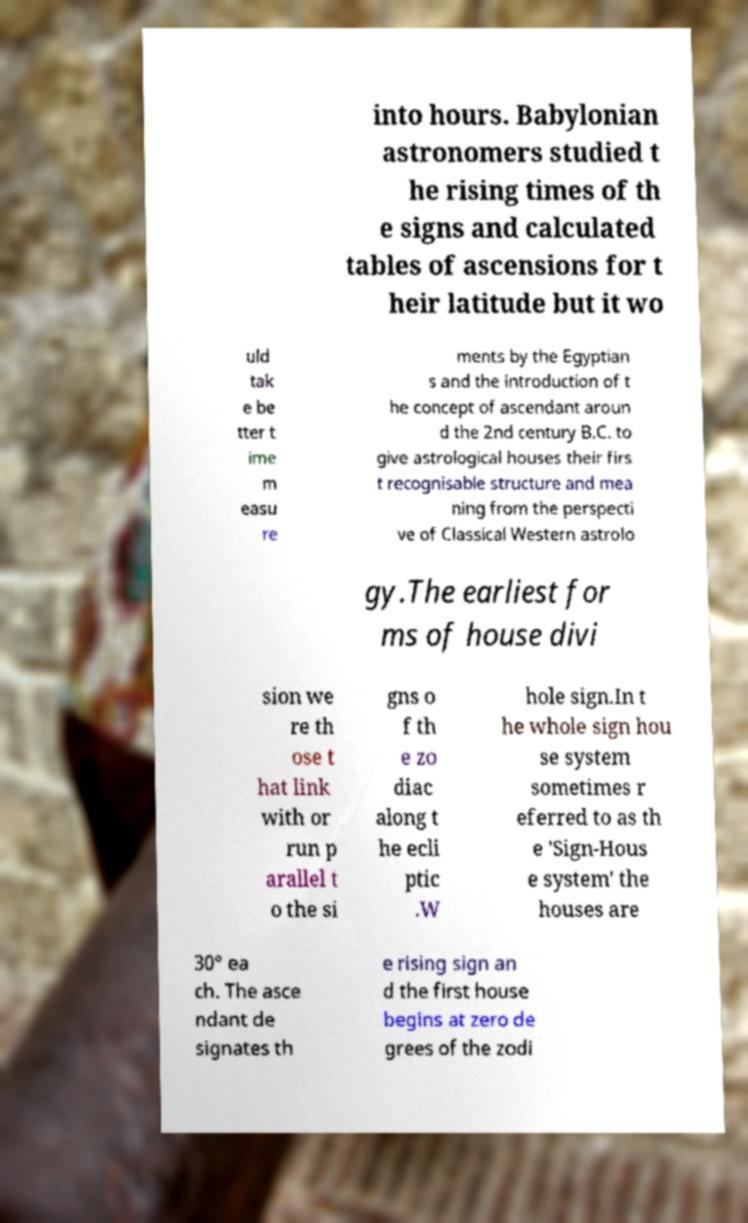What messages or text are displayed in this image? I need them in a readable, typed format. into hours. Babylonian astronomers studied t he rising times of th e signs and calculated tables of ascensions for t heir latitude but it wo uld tak e be tter t ime m easu re ments by the Egyptian s and the introduction of t he concept of ascendant aroun d the 2nd century B.C. to give astrological houses their firs t recognisable structure and mea ning from the perspecti ve of Classical Western astrolo gy.The earliest for ms of house divi sion we re th ose t hat link with or run p arallel t o the si gns o f th e zo diac along t he ecli ptic .W hole sign.In t he whole sign hou se system sometimes r eferred to as th e 'Sign-Hous e system' the houses are 30° ea ch. The asce ndant de signates th e rising sign an d the first house begins at zero de grees of the zodi 